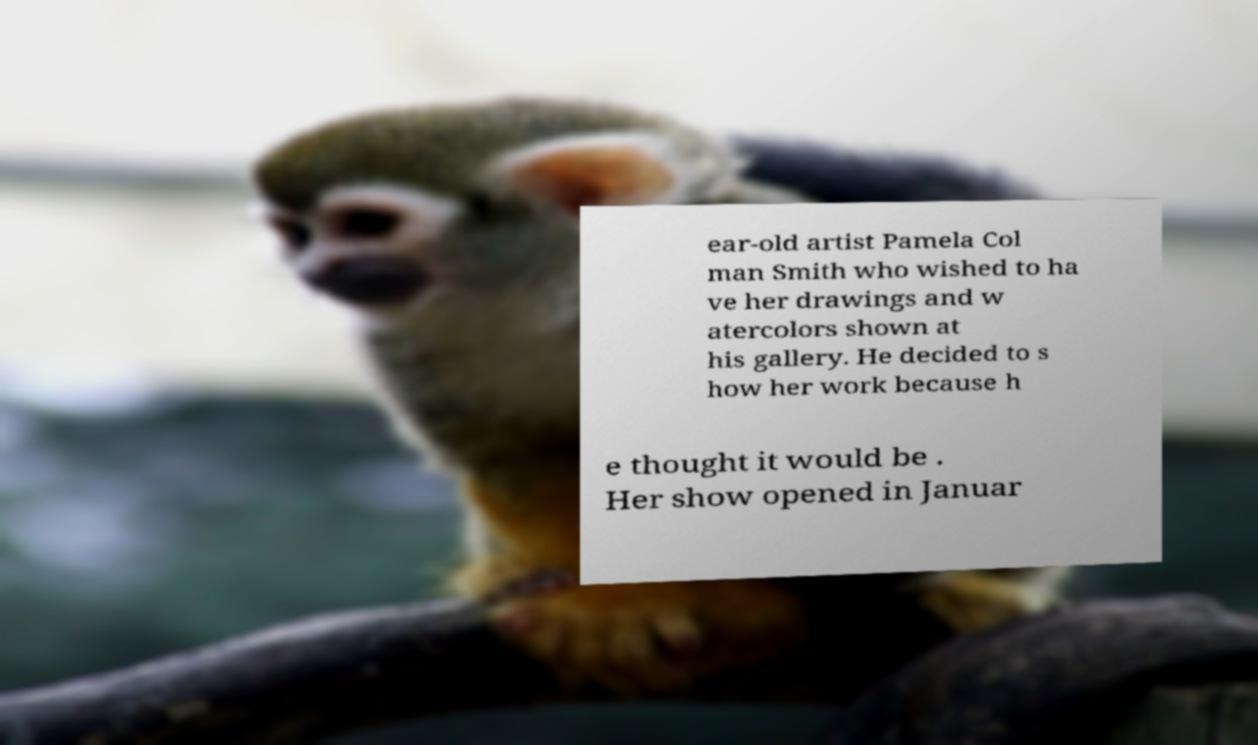Can you accurately transcribe the text from the provided image for me? ear-old artist Pamela Col man Smith who wished to ha ve her drawings and w atercolors shown at his gallery. He decided to s how her work because h e thought it would be . Her show opened in Januar 